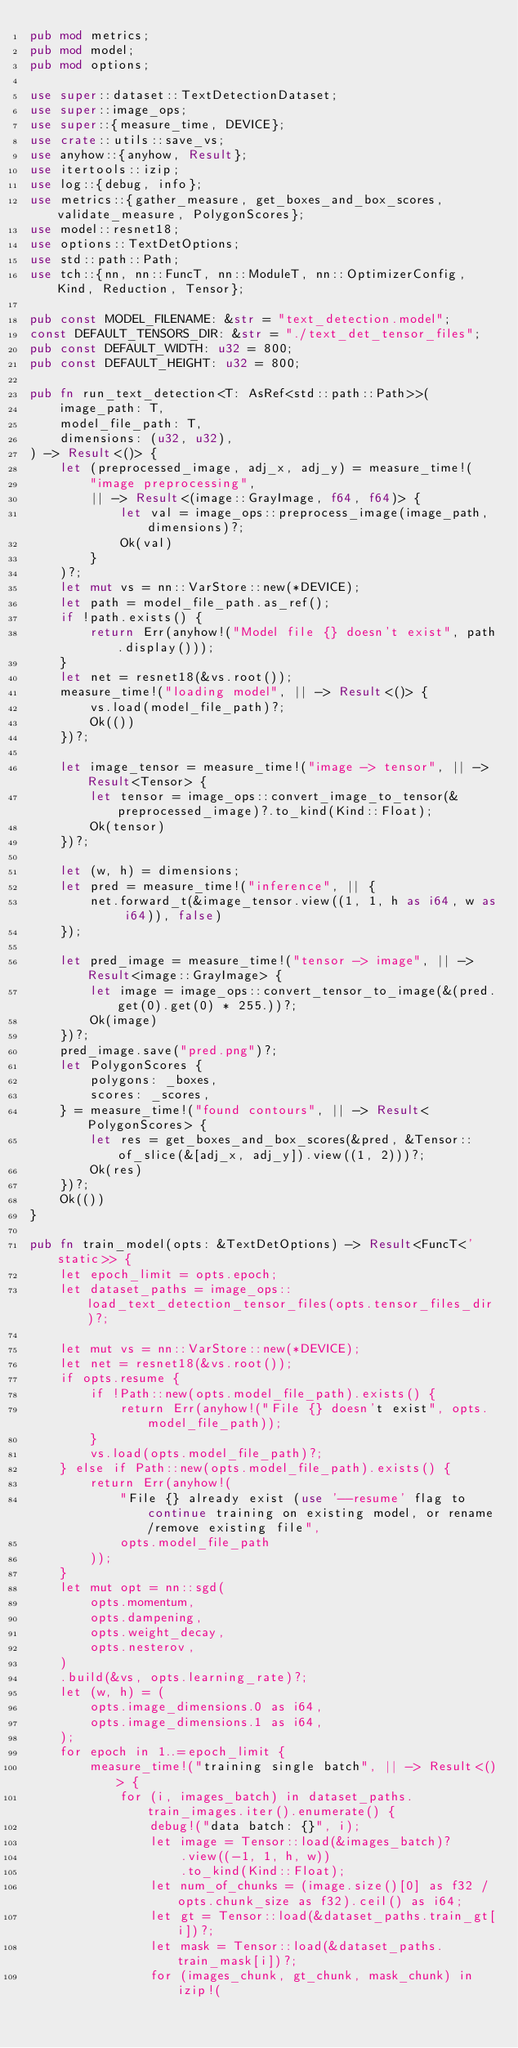<code> <loc_0><loc_0><loc_500><loc_500><_Rust_>pub mod metrics;
pub mod model;
pub mod options;

use super::dataset::TextDetectionDataset;
use super::image_ops;
use super::{measure_time, DEVICE};
use crate::utils::save_vs;
use anyhow::{anyhow, Result};
use itertools::izip;
use log::{debug, info};
use metrics::{gather_measure, get_boxes_and_box_scores, validate_measure, PolygonScores};
use model::resnet18;
use options::TextDetOptions;
use std::path::Path;
use tch::{nn, nn::FuncT, nn::ModuleT, nn::OptimizerConfig, Kind, Reduction, Tensor};

pub const MODEL_FILENAME: &str = "text_detection.model";
const DEFAULT_TENSORS_DIR: &str = "./text_det_tensor_files";
pub const DEFAULT_WIDTH: u32 = 800;
pub const DEFAULT_HEIGHT: u32 = 800;

pub fn run_text_detection<T: AsRef<std::path::Path>>(
    image_path: T,
    model_file_path: T,
    dimensions: (u32, u32),
) -> Result<()> {
    let (preprocessed_image, adj_x, adj_y) = measure_time!(
        "image preprocessing",
        || -> Result<(image::GrayImage, f64, f64)> {
            let val = image_ops::preprocess_image(image_path, dimensions)?;
            Ok(val)
        }
    )?;
    let mut vs = nn::VarStore::new(*DEVICE);
    let path = model_file_path.as_ref();
    if !path.exists() {
        return Err(anyhow!("Model file {} doesn't exist", path.display()));
    }
    let net = resnet18(&vs.root());
    measure_time!("loading model", || -> Result<()> {
        vs.load(model_file_path)?;
        Ok(())
    })?;

    let image_tensor = measure_time!("image -> tensor", || -> Result<Tensor> {
        let tensor = image_ops::convert_image_to_tensor(&preprocessed_image)?.to_kind(Kind::Float);
        Ok(tensor)
    })?;

    let (w, h) = dimensions;
    let pred = measure_time!("inference", || {
        net.forward_t(&image_tensor.view((1, 1, h as i64, w as i64)), false)
    });

    let pred_image = measure_time!("tensor -> image", || -> Result<image::GrayImage> {
        let image = image_ops::convert_tensor_to_image(&(pred.get(0).get(0) * 255.))?;
        Ok(image)
    })?;
    pred_image.save("pred.png")?;
    let PolygonScores {
        polygons: _boxes,
        scores: _scores,
    } = measure_time!("found contours", || -> Result<PolygonScores> {
        let res = get_boxes_and_box_scores(&pred, &Tensor::of_slice(&[adj_x, adj_y]).view((1, 2)))?;
        Ok(res)
    })?;
    Ok(())
}

pub fn train_model(opts: &TextDetOptions) -> Result<FuncT<'static>> {
    let epoch_limit = opts.epoch;
    let dataset_paths = image_ops::load_text_detection_tensor_files(opts.tensor_files_dir)?;

    let mut vs = nn::VarStore::new(*DEVICE);
    let net = resnet18(&vs.root());
    if opts.resume {
        if !Path::new(opts.model_file_path).exists() {
            return Err(anyhow!("File {} doesn't exist", opts.model_file_path));
        }
        vs.load(opts.model_file_path)?;
    } else if Path::new(opts.model_file_path).exists() {
        return Err(anyhow!(
            "File {} already exist (use '--resume' flag to continue training on existing model, or rename/remove existing file",
            opts.model_file_path
        ));
    }
    let mut opt = nn::sgd(
        opts.momentum,
        opts.dampening,
        opts.weight_decay,
        opts.nesterov,
    )
    .build(&vs, opts.learning_rate)?;
    let (w, h) = (
        opts.image_dimensions.0 as i64,
        opts.image_dimensions.1 as i64,
    );
    for epoch in 1..=epoch_limit {
        measure_time!("training single batch", || -> Result<()> {
            for (i, images_batch) in dataset_paths.train_images.iter().enumerate() {
                debug!("data batch: {}", i);
                let image = Tensor::load(&images_batch)?
                    .view((-1, 1, h, w))
                    .to_kind(Kind::Float);
                let num_of_chunks = (image.size()[0] as f32 / opts.chunk_size as f32).ceil() as i64;
                let gt = Tensor::load(&dataset_paths.train_gt[i])?;
                let mask = Tensor::load(&dataset_paths.train_mask[i])?;
                for (images_chunk, gt_chunk, mask_chunk) in izip!(</code> 